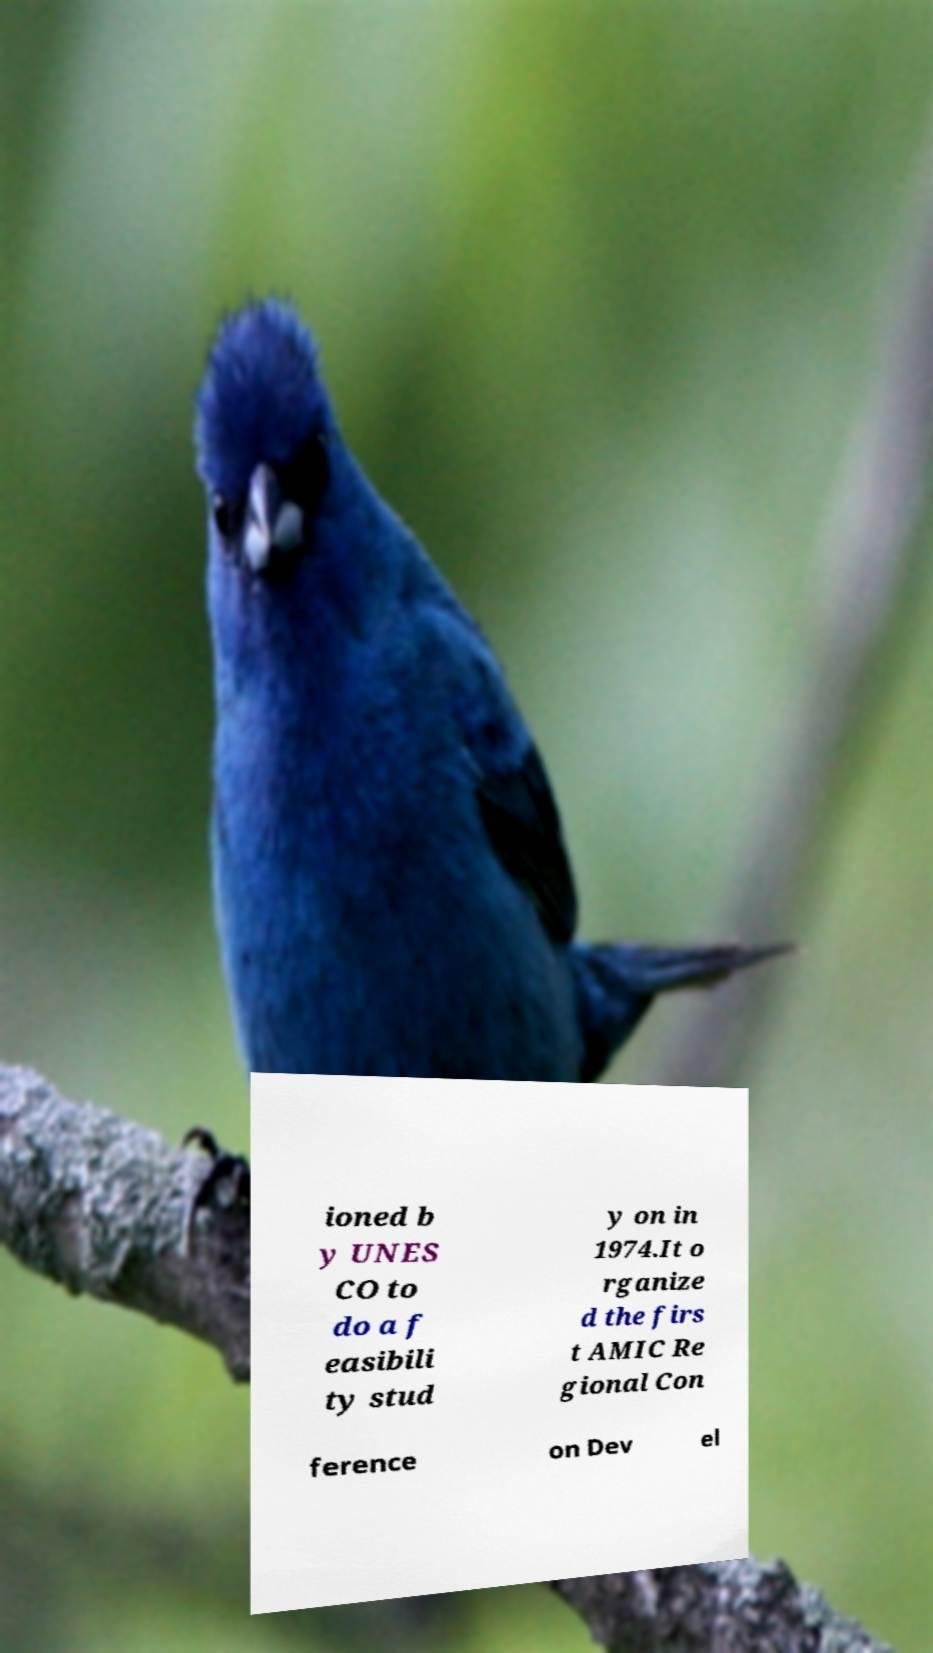There's text embedded in this image that I need extracted. Can you transcribe it verbatim? ioned b y UNES CO to do a f easibili ty stud y on in 1974.It o rganize d the firs t AMIC Re gional Con ference on Dev el 